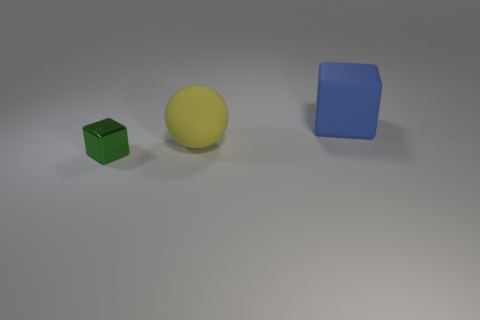How many big things are either gray blocks or blue blocks?
Offer a terse response. 1. Is there any other thing that has the same color as the sphere?
Make the answer very short. No. Are there any small green cubes to the left of the green cube?
Offer a terse response. No. What is the size of the green object that is left of the cube that is to the right of the metal thing?
Offer a very short reply. Small. Is the number of large blue matte blocks that are in front of the big blue block the same as the number of large blue blocks that are to the left of the sphere?
Make the answer very short. Yes. Are there any yellow matte spheres that are on the left side of the object that is behind the sphere?
Your answer should be very brief. Yes. What number of tiny green shiny objects are behind the big rubber thing that is in front of the cube right of the green metal block?
Give a very brief answer. 0. Are there fewer big blue blocks than small gray rubber blocks?
Make the answer very short. No. Does the matte object that is left of the large blue matte block have the same shape as the small green object in front of the blue rubber block?
Offer a terse response. No. What is the color of the large matte sphere?
Keep it short and to the point. Yellow. 